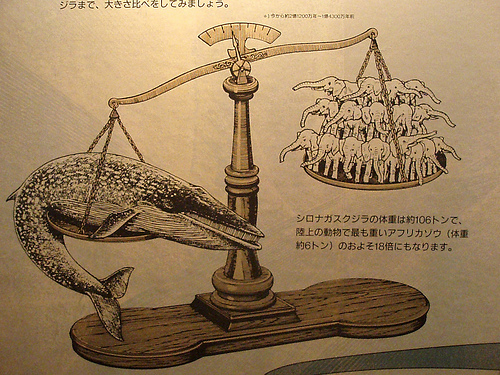<image>
Is there a whale under the paper? No. The whale is not positioned under the paper. The vertical relationship between these objects is different. 